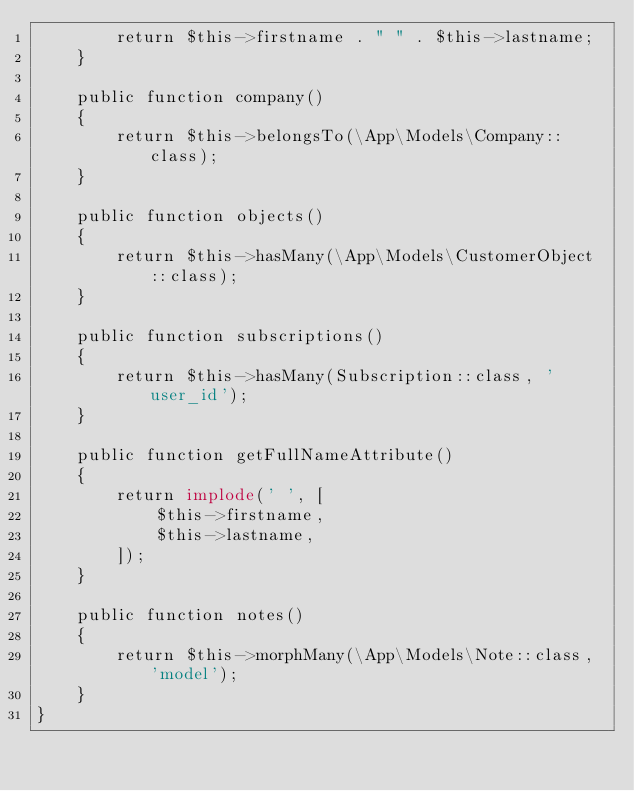<code> <loc_0><loc_0><loc_500><loc_500><_PHP_>        return $this->firstname . " " . $this->lastname;
    }

    public function company()
    {
        return $this->belongsTo(\App\Models\Company::class);
    }

    public function objects()
    {
        return $this->hasMany(\App\Models\CustomerObject::class);
    }

    public function subscriptions()
    {
        return $this->hasMany(Subscription::class, 'user_id');
    }

    public function getFullNameAttribute()
    {
        return implode(' ', [
            $this->firstname,
            $this->lastname,
        ]);
    }

    public function notes()
    {
        return $this->morphMany(\App\Models\Note::class, 'model');
    }
}
</code> 